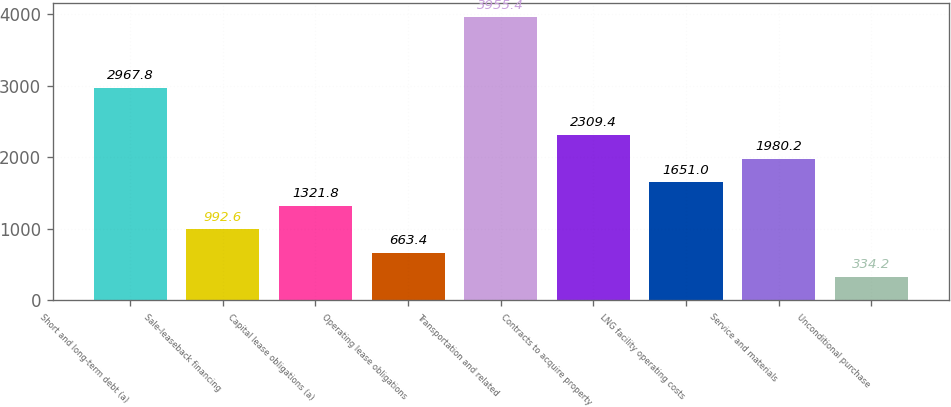Convert chart to OTSL. <chart><loc_0><loc_0><loc_500><loc_500><bar_chart><fcel>Short and long-term debt (a)<fcel>Sale-leaseback financing<fcel>Capital lease obligations (a)<fcel>Operating lease obligations<fcel>Transportation and related<fcel>Contracts to acquire property<fcel>LNG facility operating costs<fcel>Service and materials<fcel>Unconditional purchase<nl><fcel>2967.8<fcel>992.6<fcel>1321.8<fcel>663.4<fcel>3955.4<fcel>2309.4<fcel>1651<fcel>1980.2<fcel>334.2<nl></chart> 